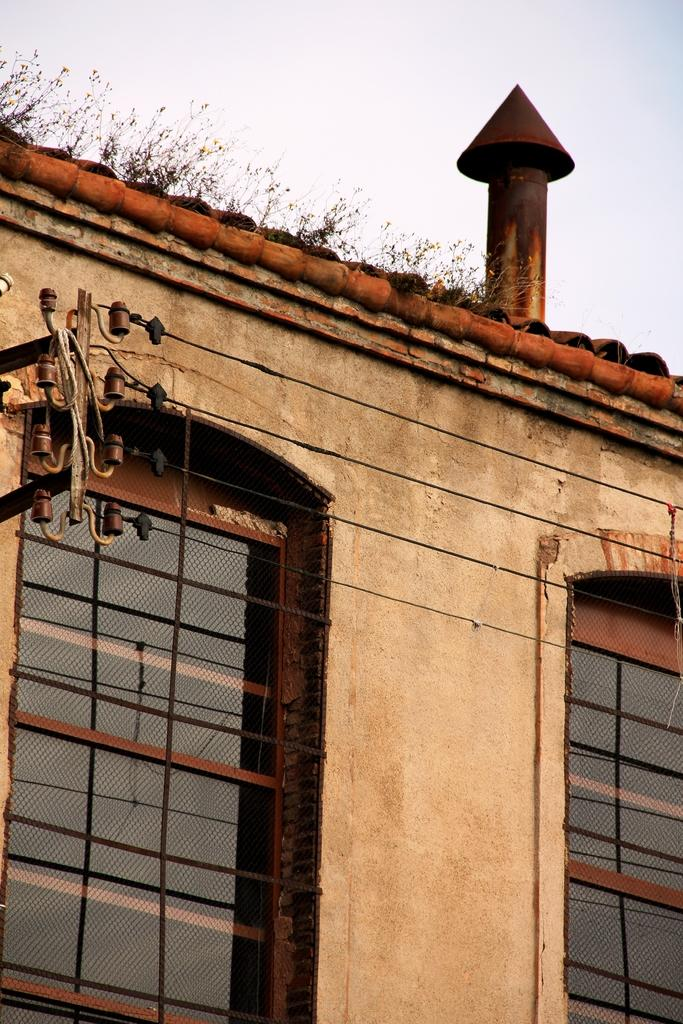What feature can be seen on the building in the image? There are windows on the building. What is located on the roof of the building? There is an exhaust pipe and grass on the roof of the building. What is visible at the top of the image? The sky is visible at the top of the image. What can be observed in the sky? Clouds are present in the sky. What type of wool is being used to knit a scarf in the image? There is no wool or scarf present in the image. Can you tell me how many oranges are on the grass on the roof of the building? There are no oranges or celery present in the image. 